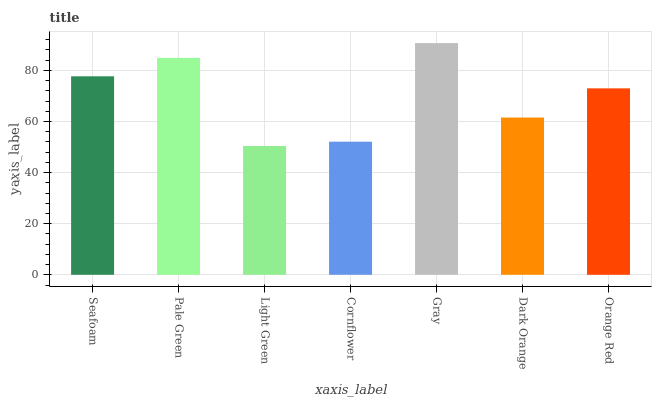Is Light Green the minimum?
Answer yes or no. Yes. Is Gray the maximum?
Answer yes or no. Yes. Is Pale Green the minimum?
Answer yes or no. No. Is Pale Green the maximum?
Answer yes or no. No. Is Pale Green greater than Seafoam?
Answer yes or no. Yes. Is Seafoam less than Pale Green?
Answer yes or no. Yes. Is Seafoam greater than Pale Green?
Answer yes or no. No. Is Pale Green less than Seafoam?
Answer yes or no. No. Is Orange Red the high median?
Answer yes or no. Yes. Is Orange Red the low median?
Answer yes or no. Yes. Is Dark Orange the high median?
Answer yes or no. No. Is Seafoam the low median?
Answer yes or no. No. 